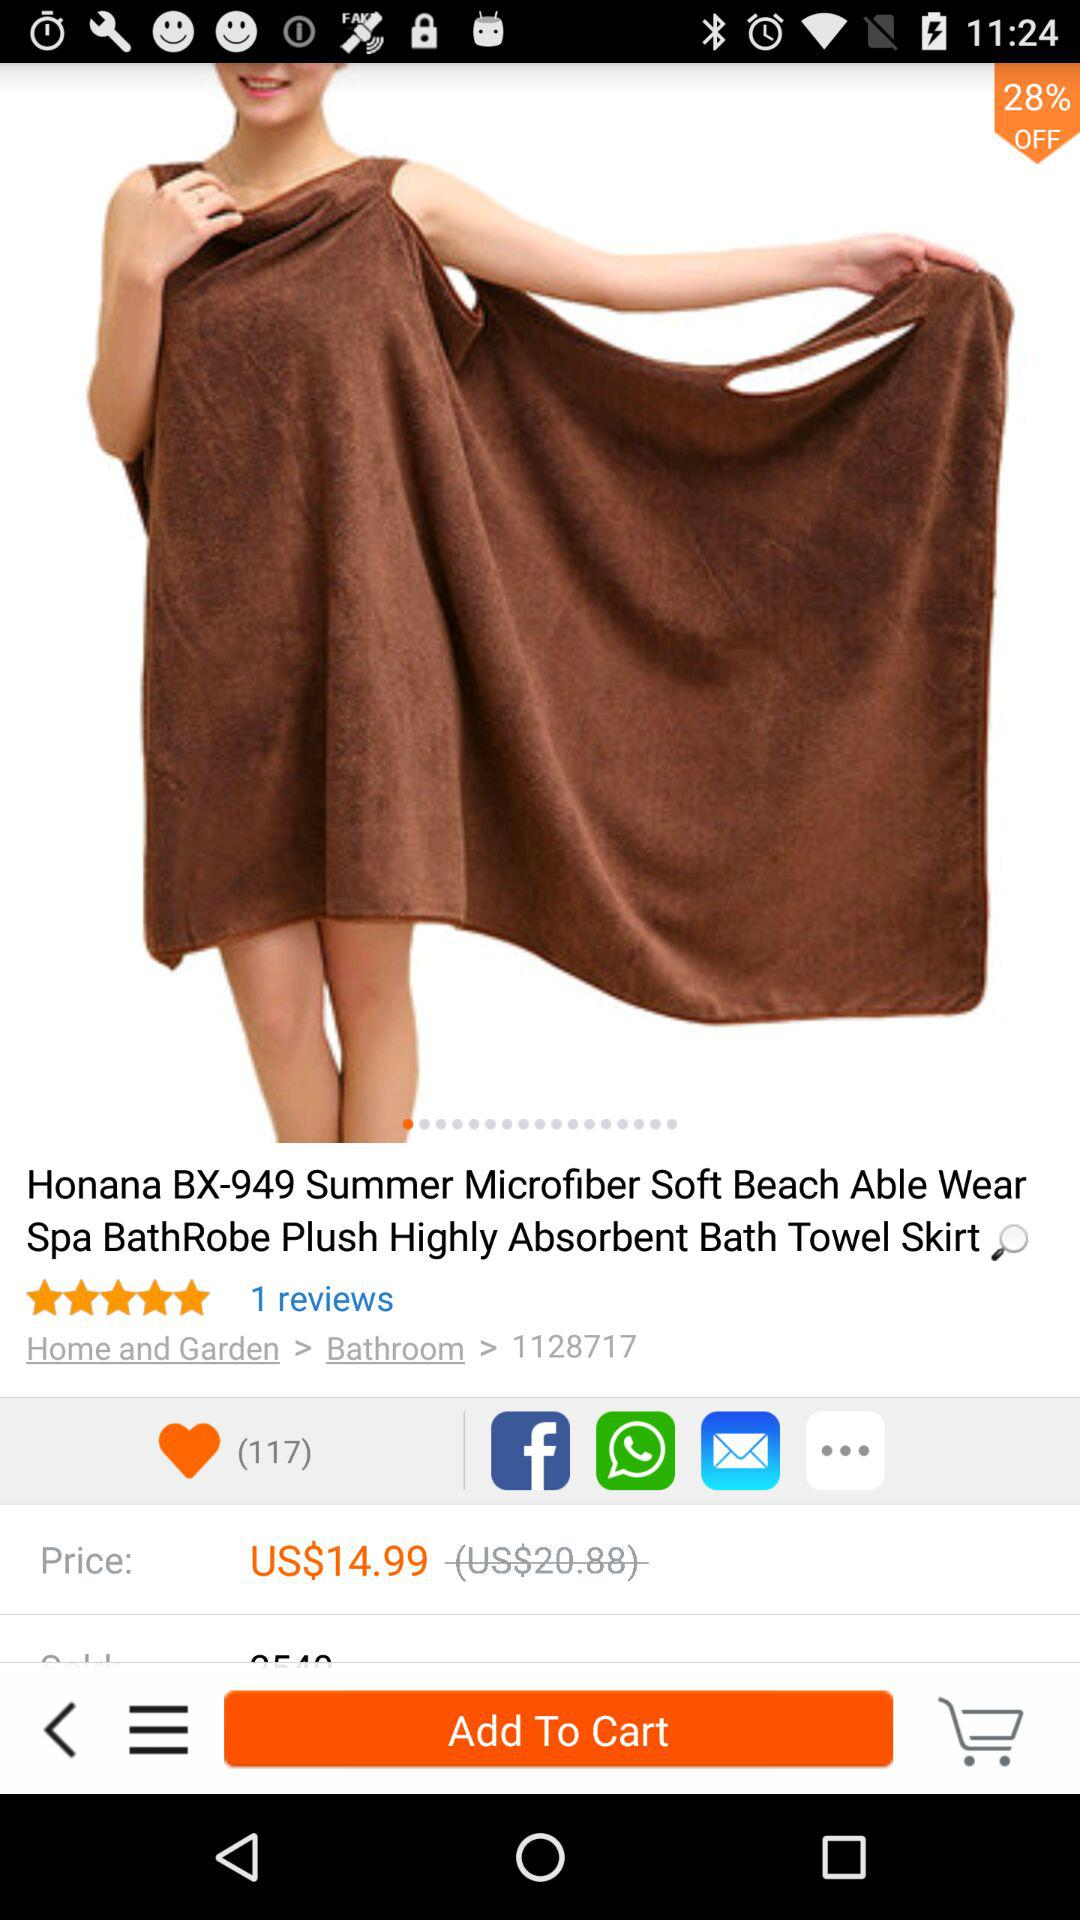What's the total number of reviews? The total number of reviews is 1. 